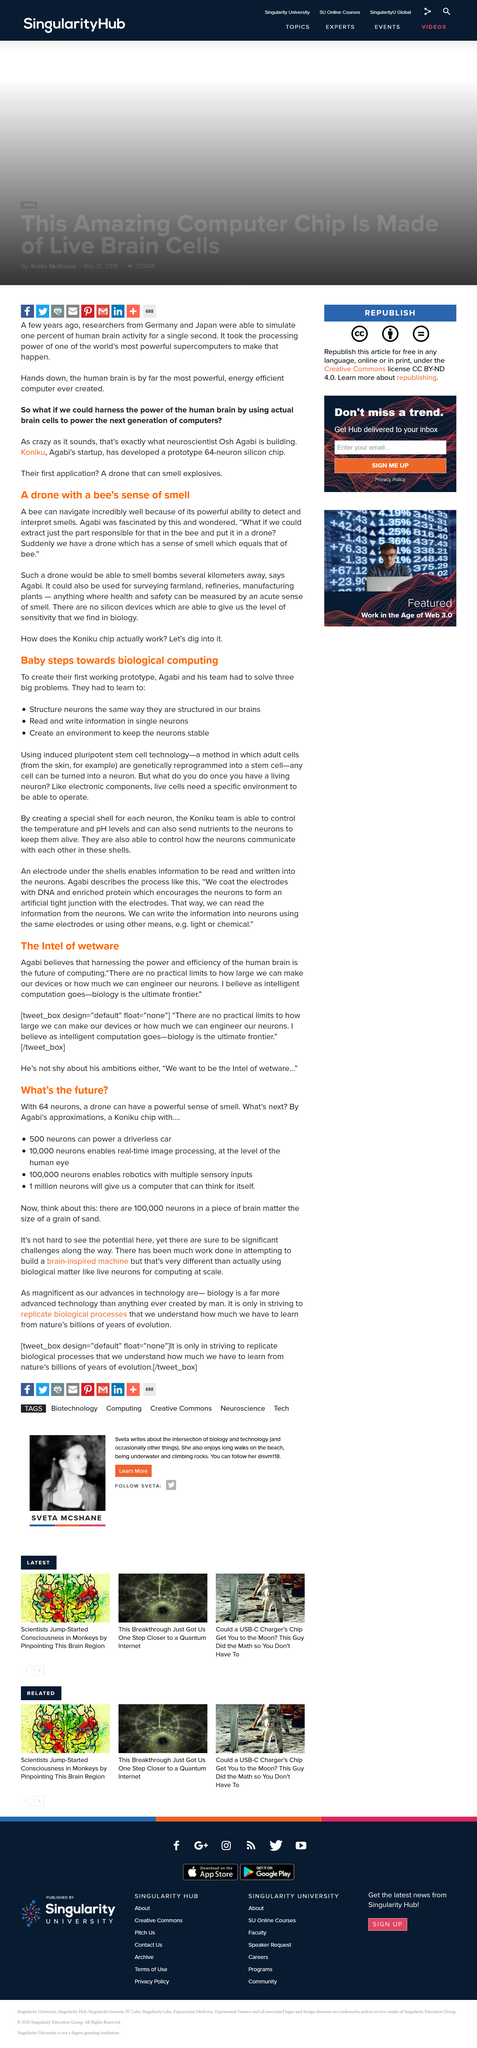Point out several critical features in this image. Adult cells are genetically programmed into pluripotent stem cells through a method known as pluripotent stem cell technology. The first working prototype was created by Agabi. Nutrients are necessary for the survival of neurons. According to Agabi, a drone equipped with an acute sense of smell can measure health and safety concerns in a variety of settings, including but not limited to industrial plants and hazardous waste sites. The Koniku chip, as described in this piece of technology, gives a background for a cutting-edge piece of technology that enables artificial intelligence with a sense of touch. 